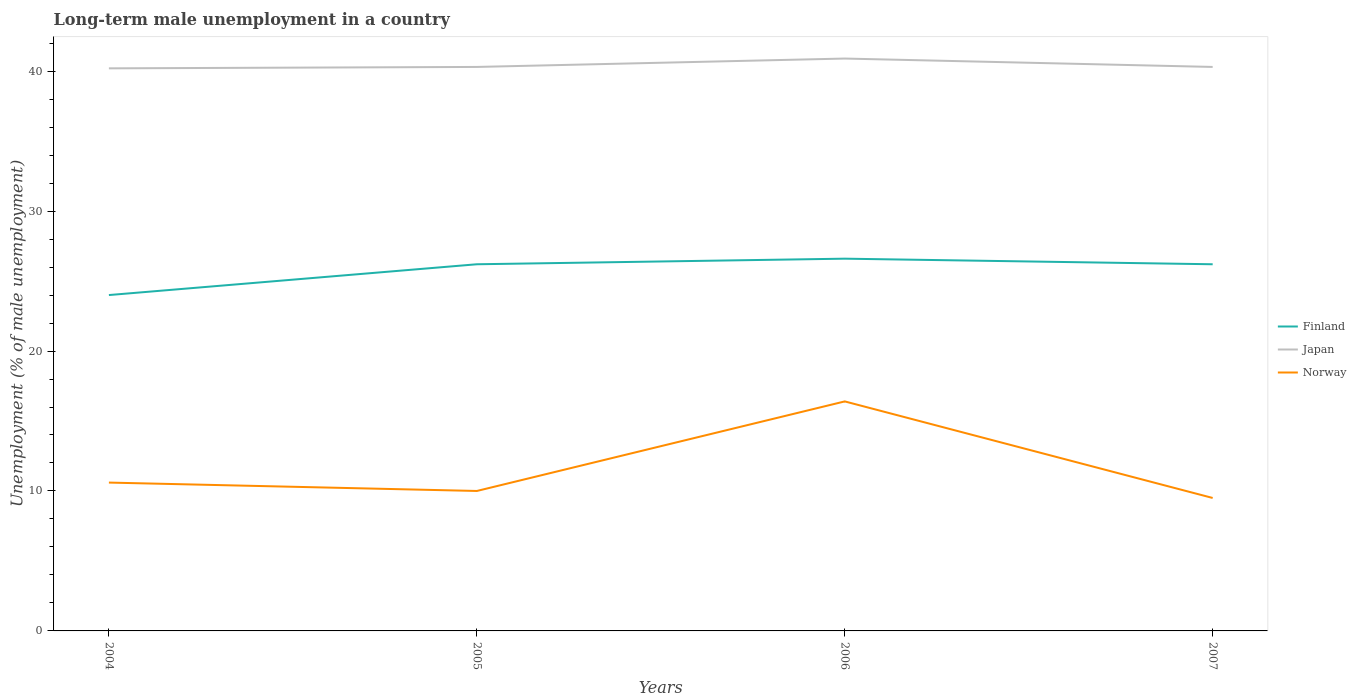How many different coloured lines are there?
Give a very brief answer. 3. Is the number of lines equal to the number of legend labels?
Offer a very short reply. Yes. What is the total percentage of long-term unemployed male population in Norway in the graph?
Keep it short and to the point. 0.6. What is the difference between the highest and the second highest percentage of long-term unemployed male population in Norway?
Offer a terse response. 6.9. What is the difference between the highest and the lowest percentage of long-term unemployed male population in Norway?
Your answer should be very brief. 1. Is the percentage of long-term unemployed male population in Finland strictly greater than the percentage of long-term unemployed male population in Japan over the years?
Ensure brevity in your answer.  Yes. How many lines are there?
Ensure brevity in your answer.  3. How many years are there in the graph?
Make the answer very short. 4. What is the difference between two consecutive major ticks on the Y-axis?
Keep it short and to the point. 10. How many legend labels are there?
Give a very brief answer. 3. How are the legend labels stacked?
Offer a very short reply. Vertical. What is the title of the graph?
Offer a very short reply. Long-term male unemployment in a country. Does "India" appear as one of the legend labels in the graph?
Make the answer very short. No. What is the label or title of the Y-axis?
Keep it short and to the point. Unemployment (% of male unemployment). What is the Unemployment (% of male unemployment) of Finland in 2004?
Offer a terse response. 24. What is the Unemployment (% of male unemployment) in Japan in 2004?
Give a very brief answer. 40.2. What is the Unemployment (% of male unemployment) of Norway in 2004?
Your response must be concise. 10.6. What is the Unemployment (% of male unemployment) of Finland in 2005?
Your answer should be very brief. 26.2. What is the Unemployment (% of male unemployment) in Japan in 2005?
Give a very brief answer. 40.3. What is the Unemployment (% of male unemployment) of Finland in 2006?
Your answer should be very brief. 26.6. What is the Unemployment (% of male unemployment) of Japan in 2006?
Make the answer very short. 40.9. What is the Unemployment (% of male unemployment) of Norway in 2006?
Ensure brevity in your answer.  16.4. What is the Unemployment (% of male unemployment) in Finland in 2007?
Make the answer very short. 26.2. What is the Unemployment (% of male unemployment) of Japan in 2007?
Offer a terse response. 40.3. What is the Unemployment (% of male unemployment) of Norway in 2007?
Provide a succinct answer. 9.5. Across all years, what is the maximum Unemployment (% of male unemployment) in Finland?
Offer a very short reply. 26.6. Across all years, what is the maximum Unemployment (% of male unemployment) in Japan?
Offer a very short reply. 40.9. Across all years, what is the maximum Unemployment (% of male unemployment) in Norway?
Your answer should be compact. 16.4. Across all years, what is the minimum Unemployment (% of male unemployment) of Japan?
Your answer should be compact. 40.2. What is the total Unemployment (% of male unemployment) in Finland in the graph?
Your response must be concise. 103. What is the total Unemployment (% of male unemployment) of Japan in the graph?
Offer a terse response. 161.7. What is the total Unemployment (% of male unemployment) of Norway in the graph?
Your response must be concise. 46.5. What is the difference between the Unemployment (% of male unemployment) in Finland in 2004 and that in 2005?
Give a very brief answer. -2.2. What is the difference between the Unemployment (% of male unemployment) in Japan in 2004 and that in 2005?
Provide a succinct answer. -0.1. What is the difference between the Unemployment (% of male unemployment) of Norway in 2004 and that in 2005?
Provide a short and direct response. 0.6. What is the difference between the Unemployment (% of male unemployment) in Finland in 2004 and that in 2006?
Provide a succinct answer. -2.6. What is the difference between the Unemployment (% of male unemployment) of Japan in 2004 and that in 2006?
Give a very brief answer. -0.7. What is the difference between the Unemployment (% of male unemployment) in Japan in 2004 and that in 2007?
Offer a terse response. -0.1. What is the difference between the Unemployment (% of male unemployment) of Norway in 2004 and that in 2007?
Provide a short and direct response. 1.1. What is the difference between the Unemployment (% of male unemployment) in Japan in 2005 and that in 2007?
Ensure brevity in your answer.  0. What is the difference between the Unemployment (% of male unemployment) of Norway in 2005 and that in 2007?
Keep it short and to the point. 0.5. What is the difference between the Unemployment (% of male unemployment) of Finland in 2006 and that in 2007?
Ensure brevity in your answer.  0.4. What is the difference between the Unemployment (% of male unemployment) of Japan in 2006 and that in 2007?
Your answer should be compact. 0.6. What is the difference between the Unemployment (% of male unemployment) in Norway in 2006 and that in 2007?
Provide a short and direct response. 6.9. What is the difference between the Unemployment (% of male unemployment) of Finland in 2004 and the Unemployment (% of male unemployment) of Japan in 2005?
Your answer should be compact. -16.3. What is the difference between the Unemployment (% of male unemployment) of Finland in 2004 and the Unemployment (% of male unemployment) of Norway in 2005?
Provide a succinct answer. 14. What is the difference between the Unemployment (% of male unemployment) in Japan in 2004 and the Unemployment (% of male unemployment) in Norway in 2005?
Provide a succinct answer. 30.2. What is the difference between the Unemployment (% of male unemployment) of Finland in 2004 and the Unemployment (% of male unemployment) of Japan in 2006?
Keep it short and to the point. -16.9. What is the difference between the Unemployment (% of male unemployment) in Finland in 2004 and the Unemployment (% of male unemployment) in Norway in 2006?
Keep it short and to the point. 7.6. What is the difference between the Unemployment (% of male unemployment) of Japan in 2004 and the Unemployment (% of male unemployment) of Norway in 2006?
Provide a succinct answer. 23.8. What is the difference between the Unemployment (% of male unemployment) of Finland in 2004 and the Unemployment (% of male unemployment) of Japan in 2007?
Provide a short and direct response. -16.3. What is the difference between the Unemployment (% of male unemployment) of Finland in 2004 and the Unemployment (% of male unemployment) of Norway in 2007?
Offer a terse response. 14.5. What is the difference between the Unemployment (% of male unemployment) of Japan in 2004 and the Unemployment (% of male unemployment) of Norway in 2007?
Ensure brevity in your answer.  30.7. What is the difference between the Unemployment (% of male unemployment) of Finland in 2005 and the Unemployment (% of male unemployment) of Japan in 2006?
Make the answer very short. -14.7. What is the difference between the Unemployment (% of male unemployment) of Japan in 2005 and the Unemployment (% of male unemployment) of Norway in 2006?
Your answer should be compact. 23.9. What is the difference between the Unemployment (% of male unemployment) of Finland in 2005 and the Unemployment (% of male unemployment) of Japan in 2007?
Provide a succinct answer. -14.1. What is the difference between the Unemployment (% of male unemployment) in Japan in 2005 and the Unemployment (% of male unemployment) in Norway in 2007?
Your answer should be very brief. 30.8. What is the difference between the Unemployment (% of male unemployment) in Finland in 2006 and the Unemployment (% of male unemployment) in Japan in 2007?
Your answer should be compact. -13.7. What is the difference between the Unemployment (% of male unemployment) in Japan in 2006 and the Unemployment (% of male unemployment) in Norway in 2007?
Your response must be concise. 31.4. What is the average Unemployment (% of male unemployment) of Finland per year?
Provide a succinct answer. 25.75. What is the average Unemployment (% of male unemployment) of Japan per year?
Your answer should be very brief. 40.42. What is the average Unemployment (% of male unemployment) in Norway per year?
Your response must be concise. 11.62. In the year 2004, what is the difference between the Unemployment (% of male unemployment) of Finland and Unemployment (% of male unemployment) of Japan?
Your answer should be compact. -16.2. In the year 2004, what is the difference between the Unemployment (% of male unemployment) in Finland and Unemployment (% of male unemployment) in Norway?
Offer a very short reply. 13.4. In the year 2004, what is the difference between the Unemployment (% of male unemployment) of Japan and Unemployment (% of male unemployment) of Norway?
Your response must be concise. 29.6. In the year 2005, what is the difference between the Unemployment (% of male unemployment) of Finland and Unemployment (% of male unemployment) of Japan?
Keep it short and to the point. -14.1. In the year 2005, what is the difference between the Unemployment (% of male unemployment) in Finland and Unemployment (% of male unemployment) in Norway?
Your answer should be compact. 16.2. In the year 2005, what is the difference between the Unemployment (% of male unemployment) of Japan and Unemployment (% of male unemployment) of Norway?
Offer a very short reply. 30.3. In the year 2006, what is the difference between the Unemployment (% of male unemployment) of Finland and Unemployment (% of male unemployment) of Japan?
Keep it short and to the point. -14.3. In the year 2007, what is the difference between the Unemployment (% of male unemployment) in Finland and Unemployment (% of male unemployment) in Japan?
Give a very brief answer. -14.1. In the year 2007, what is the difference between the Unemployment (% of male unemployment) of Finland and Unemployment (% of male unemployment) of Norway?
Provide a succinct answer. 16.7. In the year 2007, what is the difference between the Unemployment (% of male unemployment) in Japan and Unemployment (% of male unemployment) in Norway?
Keep it short and to the point. 30.8. What is the ratio of the Unemployment (% of male unemployment) in Finland in 2004 to that in 2005?
Offer a terse response. 0.92. What is the ratio of the Unemployment (% of male unemployment) of Norway in 2004 to that in 2005?
Make the answer very short. 1.06. What is the ratio of the Unemployment (% of male unemployment) of Finland in 2004 to that in 2006?
Your response must be concise. 0.9. What is the ratio of the Unemployment (% of male unemployment) of Japan in 2004 to that in 2006?
Your answer should be very brief. 0.98. What is the ratio of the Unemployment (% of male unemployment) in Norway in 2004 to that in 2006?
Keep it short and to the point. 0.65. What is the ratio of the Unemployment (% of male unemployment) in Finland in 2004 to that in 2007?
Give a very brief answer. 0.92. What is the ratio of the Unemployment (% of male unemployment) of Norway in 2004 to that in 2007?
Make the answer very short. 1.12. What is the ratio of the Unemployment (% of male unemployment) of Norway in 2005 to that in 2006?
Make the answer very short. 0.61. What is the ratio of the Unemployment (% of male unemployment) of Japan in 2005 to that in 2007?
Provide a succinct answer. 1. What is the ratio of the Unemployment (% of male unemployment) in Norway in 2005 to that in 2007?
Provide a short and direct response. 1.05. What is the ratio of the Unemployment (% of male unemployment) of Finland in 2006 to that in 2007?
Your answer should be very brief. 1.02. What is the ratio of the Unemployment (% of male unemployment) of Japan in 2006 to that in 2007?
Ensure brevity in your answer.  1.01. What is the ratio of the Unemployment (% of male unemployment) in Norway in 2006 to that in 2007?
Offer a very short reply. 1.73. What is the difference between the highest and the second highest Unemployment (% of male unemployment) of Finland?
Your answer should be very brief. 0.4. What is the difference between the highest and the second highest Unemployment (% of male unemployment) in Japan?
Keep it short and to the point. 0.6. What is the difference between the highest and the second highest Unemployment (% of male unemployment) of Norway?
Offer a very short reply. 5.8. What is the difference between the highest and the lowest Unemployment (% of male unemployment) of Finland?
Provide a short and direct response. 2.6. What is the difference between the highest and the lowest Unemployment (% of male unemployment) of Japan?
Give a very brief answer. 0.7. 